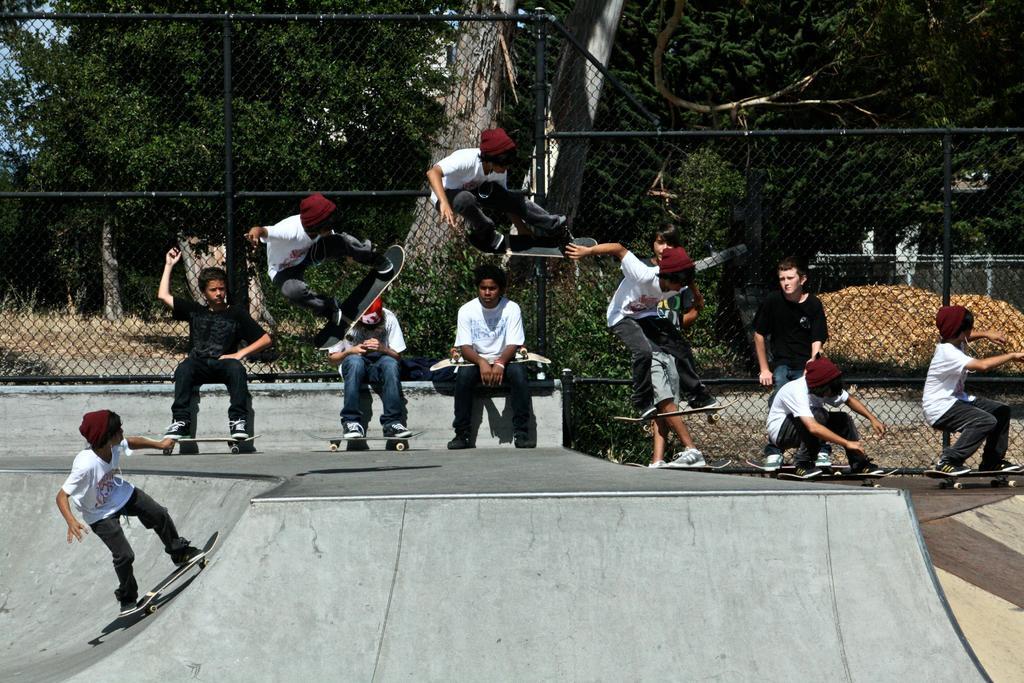In one or two sentences, can you explain what this image depicts? In the background we can see the trees, plants and fence. In this picture we can see people skating with skateboard on an inclined platform. Near to the fence we can see people sitting. We can see people in the air with skateboards. 